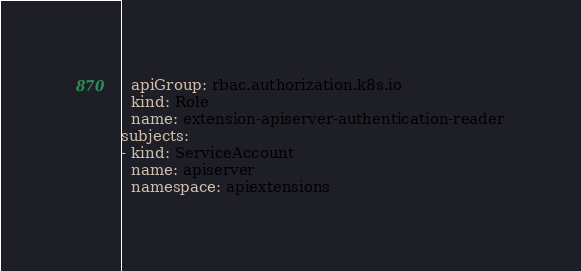<code> <loc_0><loc_0><loc_500><loc_500><_YAML_>  apiGroup: rbac.authorization.k8s.io
  kind: Role
  name: extension-apiserver-authentication-reader
subjects:
- kind: ServiceAccount
  name: apiserver
  namespace: apiextensions
</code> 